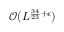<formula> <loc_0><loc_0><loc_500><loc_500>\mathcal { O } ( L ^ { \frac { 3 4 } { 2 3 } + \epsilon } )</formula> 